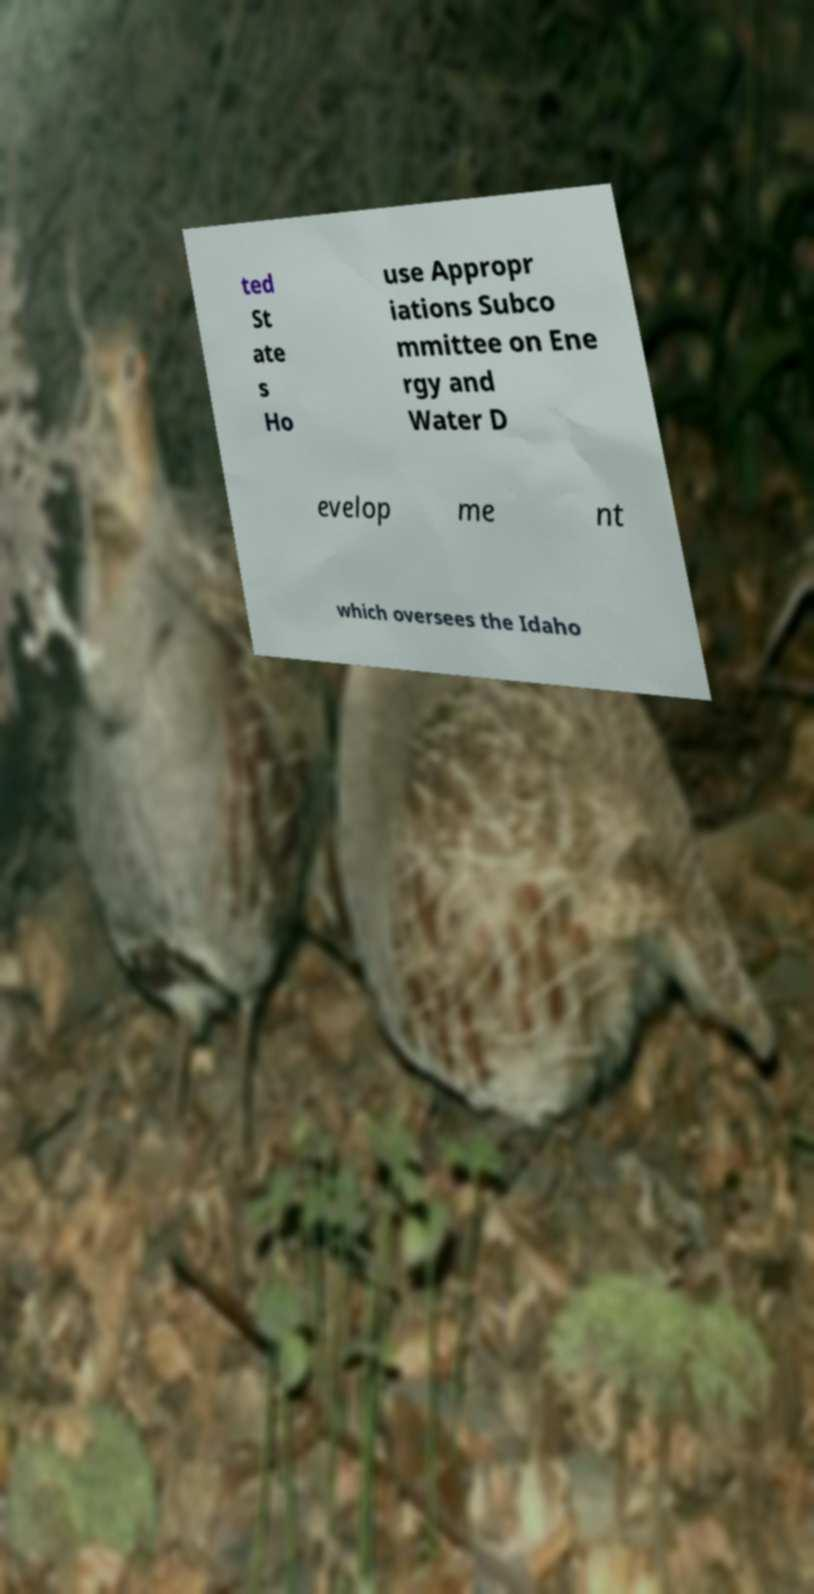Could you extract and type out the text from this image? ted St ate s Ho use Appropr iations Subco mmittee on Ene rgy and Water D evelop me nt which oversees the Idaho 